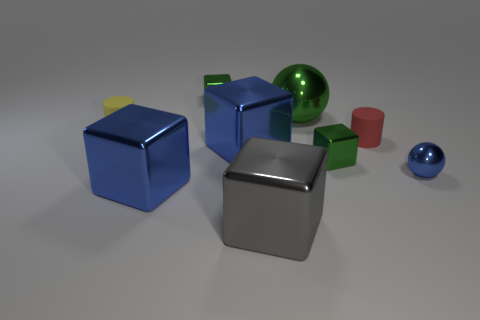How many tiny things are the same color as the big metallic ball?
Provide a succinct answer. 2. There is a sphere behind the blue thing right of the big ball; what number of green cubes are on the right side of it?
Offer a very short reply. 1. Does the sphere on the left side of the tiny blue thing have the same color as the tiny sphere?
Make the answer very short. No. How many other things are the same shape as the red rubber object?
Give a very brief answer. 1. What number of other objects are there of the same material as the small yellow object?
Ensure brevity in your answer.  1. What material is the large block in front of the blue cube on the left side of the big blue metal block that is behind the blue metal sphere?
Offer a very short reply. Metal. Does the large gray thing have the same material as the red cylinder?
Your answer should be very brief. No. How many spheres are green metal objects or small red things?
Make the answer very short. 1. What is the color of the small shiny cube that is to the left of the gray object?
Offer a terse response. Green. What number of metal objects are either tiny yellow things or small blue things?
Offer a terse response. 1. 